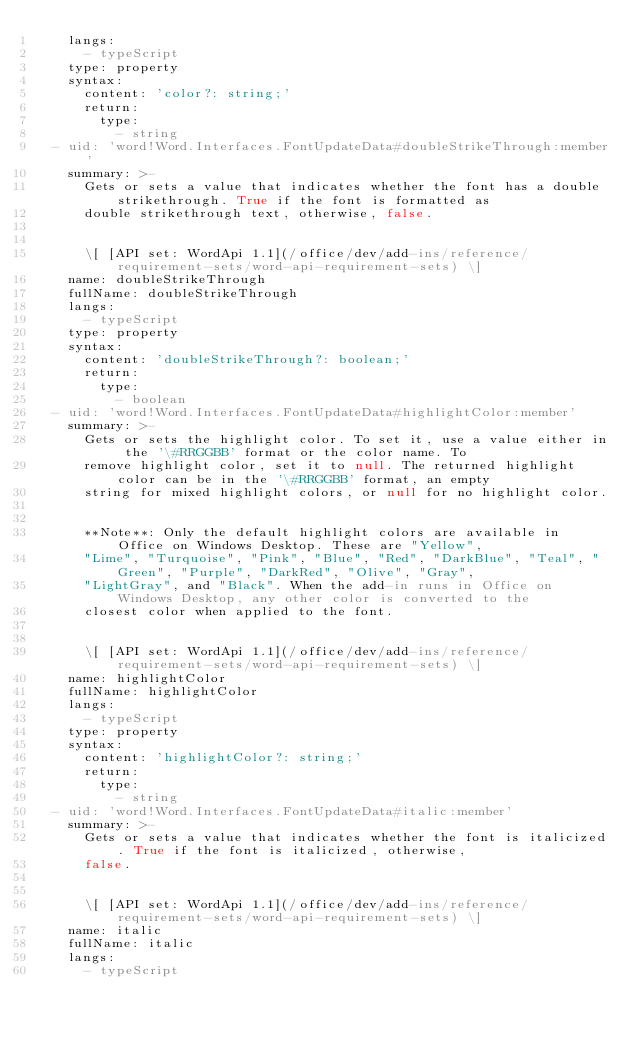Convert code to text. <code><loc_0><loc_0><loc_500><loc_500><_YAML_>    langs:
      - typeScript
    type: property
    syntax:
      content: 'color?: string;'
      return:
        type:
          - string
  - uid: 'word!Word.Interfaces.FontUpdateData#doubleStrikeThrough:member'
    summary: >-
      Gets or sets a value that indicates whether the font has a double strikethrough. True if the font is formatted as
      double strikethrough text, otherwise, false.


      \[ [API set: WordApi 1.1](/office/dev/add-ins/reference/requirement-sets/word-api-requirement-sets) \]
    name: doubleStrikeThrough
    fullName: doubleStrikeThrough
    langs:
      - typeScript
    type: property
    syntax:
      content: 'doubleStrikeThrough?: boolean;'
      return:
        type:
          - boolean
  - uid: 'word!Word.Interfaces.FontUpdateData#highlightColor:member'
    summary: >-
      Gets or sets the highlight color. To set it, use a value either in the '\#RRGGBB' format or the color name. To
      remove highlight color, set it to null. The returned highlight color can be in the '\#RRGGBB' format, an empty
      string for mixed highlight colors, or null for no highlight color.


      **Note**: Only the default highlight colors are available in Office on Windows Desktop. These are "Yellow",
      "Lime", "Turquoise", "Pink", "Blue", "Red", "DarkBlue", "Teal", "Green", "Purple", "DarkRed", "Olive", "Gray",
      "LightGray", and "Black". When the add-in runs in Office on Windows Desktop, any other color is converted to the
      closest color when applied to the font.


      \[ [API set: WordApi 1.1](/office/dev/add-ins/reference/requirement-sets/word-api-requirement-sets) \]
    name: highlightColor
    fullName: highlightColor
    langs:
      - typeScript
    type: property
    syntax:
      content: 'highlightColor?: string;'
      return:
        type:
          - string
  - uid: 'word!Word.Interfaces.FontUpdateData#italic:member'
    summary: >-
      Gets or sets a value that indicates whether the font is italicized. True if the font is italicized, otherwise,
      false.


      \[ [API set: WordApi 1.1](/office/dev/add-ins/reference/requirement-sets/word-api-requirement-sets) \]
    name: italic
    fullName: italic
    langs:
      - typeScript</code> 